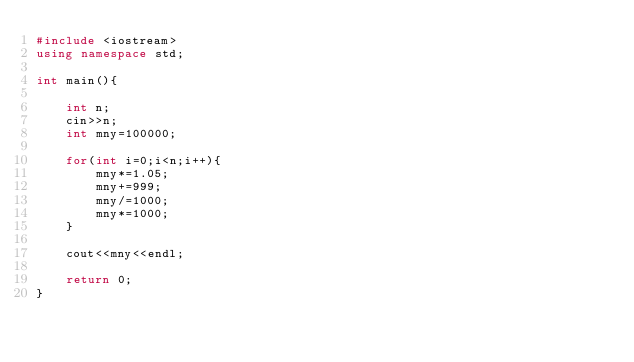<code> <loc_0><loc_0><loc_500><loc_500><_C++_>#include <iostream>
using namespace std;

int main(){
	
	int n;
	cin>>n;
	int mny=100000;
	
	for(int i=0;i<n;i++){
		mny*=1.05;
		mny+=999;
		mny/=1000;
		mny*=1000;
	}
	
	cout<<mny<<endl;
	
	return 0;
}
</code> 